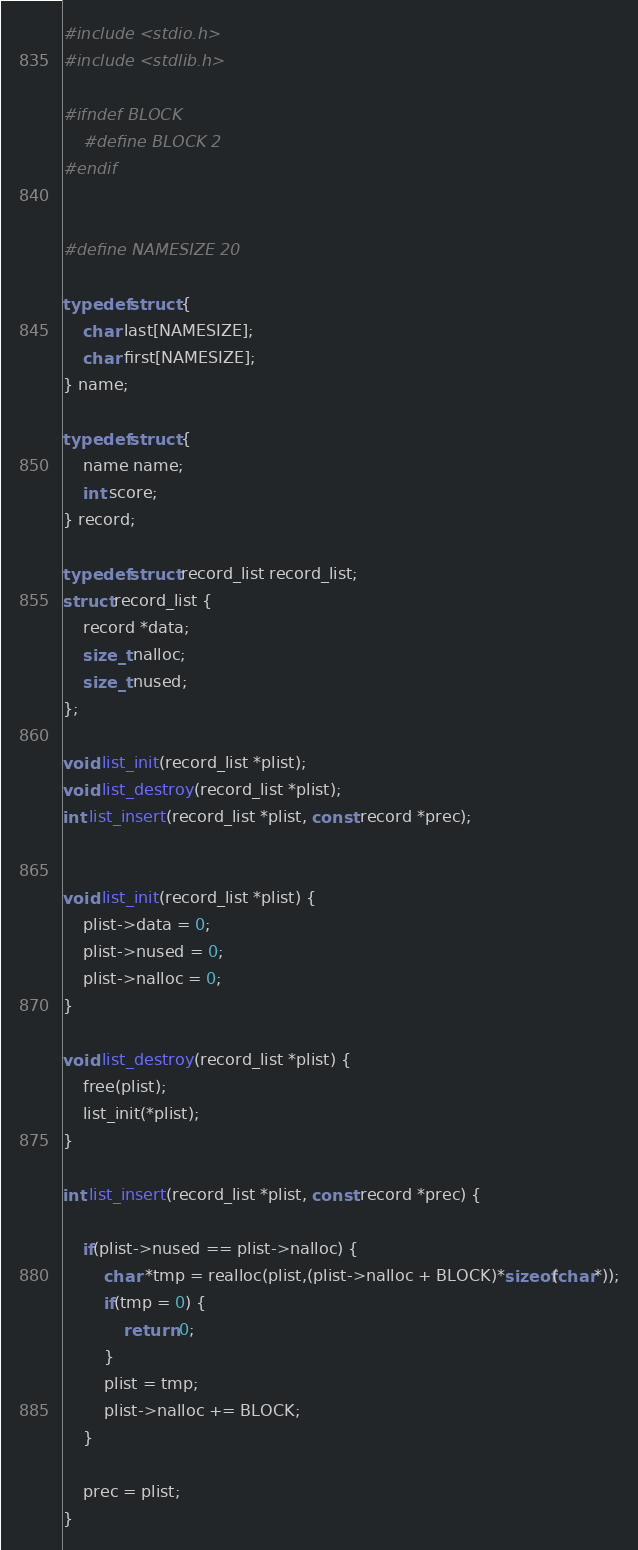<code> <loc_0><loc_0><loc_500><loc_500><_C_>#include <stdio.h>
#include <stdlib.h>

#ifndef BLOCK
	#define BLOCK 2
#endif


#define NAMESIZE 20

typedef struct {
	char last[NAMESIZE];
	char first[NAMESIZE];
} name;

typedef struct {
	name name;
	int score;
} record;

typedef struct record_list record_list;
struct record_list {
	record *data;
	size_t nalloc;
	size_t nused;
};

void list_init(record_list *plist);
void list_destroy(record_list *plist);
int list_insert(record_list *plist, const record *prec);


void list_init(record_list *plist) {
	plist->data = 0;
	plist->nused = 0;
	plist->nalloc = 0;
}

void list_destroy(record_list *plist) {
	free(plist);
	list_init(*plist);
}

int list_insert(record_list *plist, const record *prec) {
	
	if(plist->nused == plist->nalloc) {
		char *tmp = realloc(plist,(plist->nalloc + BLOCK)*sizeof(char*));
		if(tmp = 0) {
			return 0;
		}
		plist = tmp;
		plist->nalloc += BLOCK;
	}
	
	prec = plist;
}</code> 